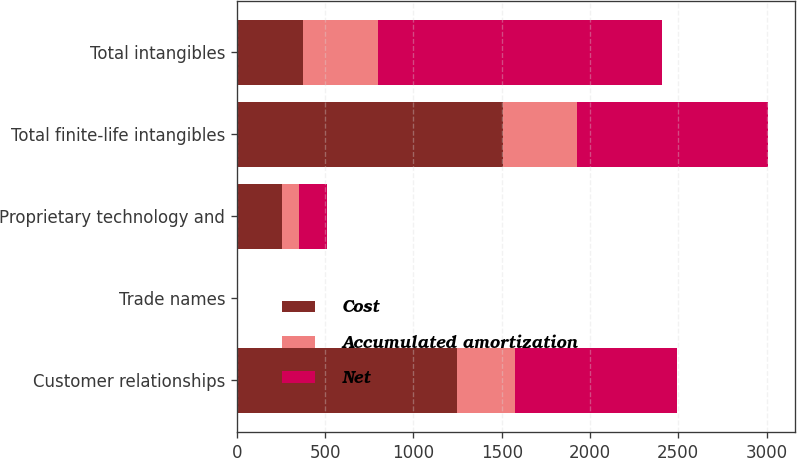<chart> <loc_0><loc_0><loc_500><loc_500><stacked_bar_chart><ecel><fcel>Customer relationships<fcel>Trade names<fcel>Proprietary technology and<fcel>Total finite-life intangibles<fcel>Total intangibles<nl><fcel>Cost<fcel>1247.8<fcel>2<fcel>255.7<fcel>1505.5<fcel>374.1<nl><fcel>Accumulated amortization<fcel>325.2<fcel>1.1<fcel>96.7<fcel>423<fcel>423<nl><fcel>Net<fcel>922.6<fcel>0.9<fcel>159<fcel>1082.5<fcel>1608.1<nl></chart> 